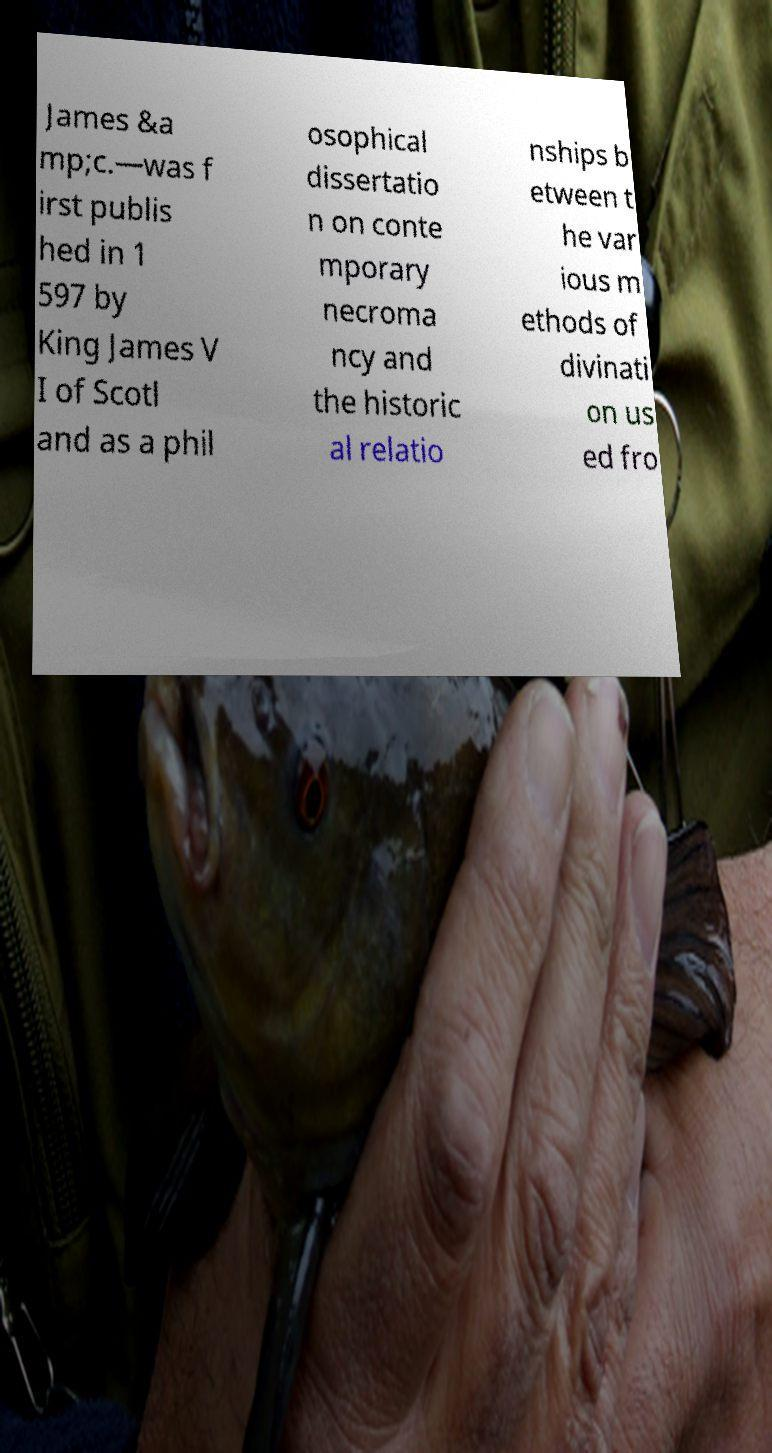For documentation purposes, I need the text within this image transcribed. Could you provide that? James &a mp;c.—was f irst publis hed in 1 597 by King James V I of Scotl and as a phil osophical dissertatio n on conte mporary necroma ncy and the historic al relatio nships b etween t he var ious m ethods of divinati on us ed fro 